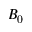<formula> <loc_0><loc_0><loc_500><loc_500>B _ { 0 }</formula> 